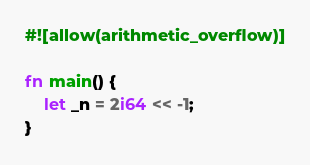Convert code to text. <code><loc_0><loc_0><loc_500><loc_500><_Rust_>#![allow(arithmetic_overflow)]

fn main() {
    let _n = 2i64 << -1;
}
</code> 